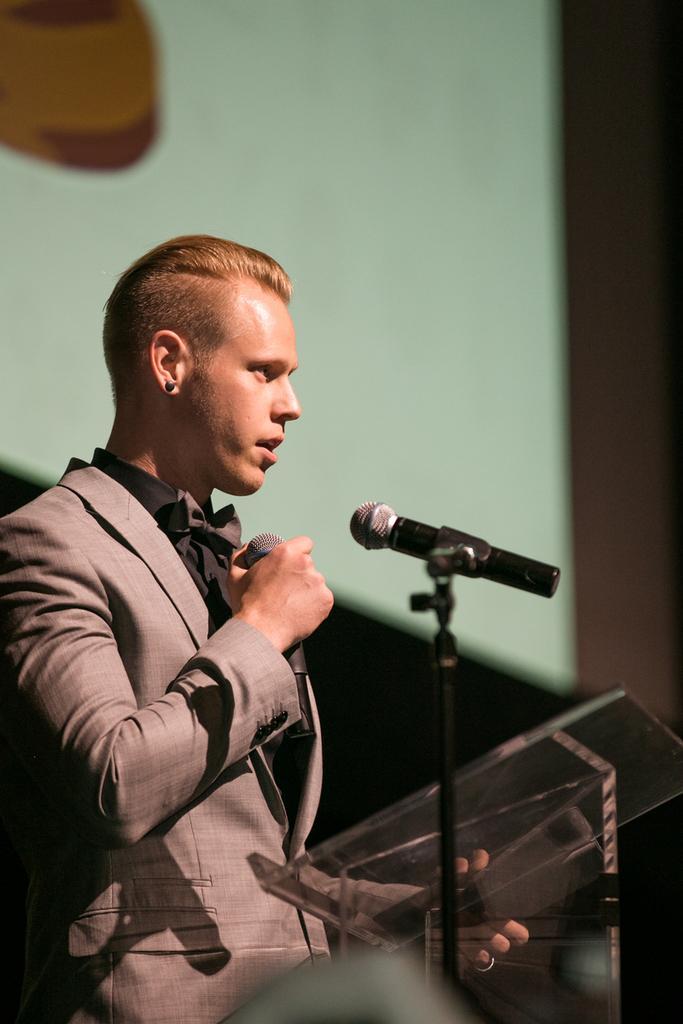Can you describe this image briefly? In this image I see a man who is holding a mic and he is standing in front of a podium and I can also see that he is wearing a suit. 